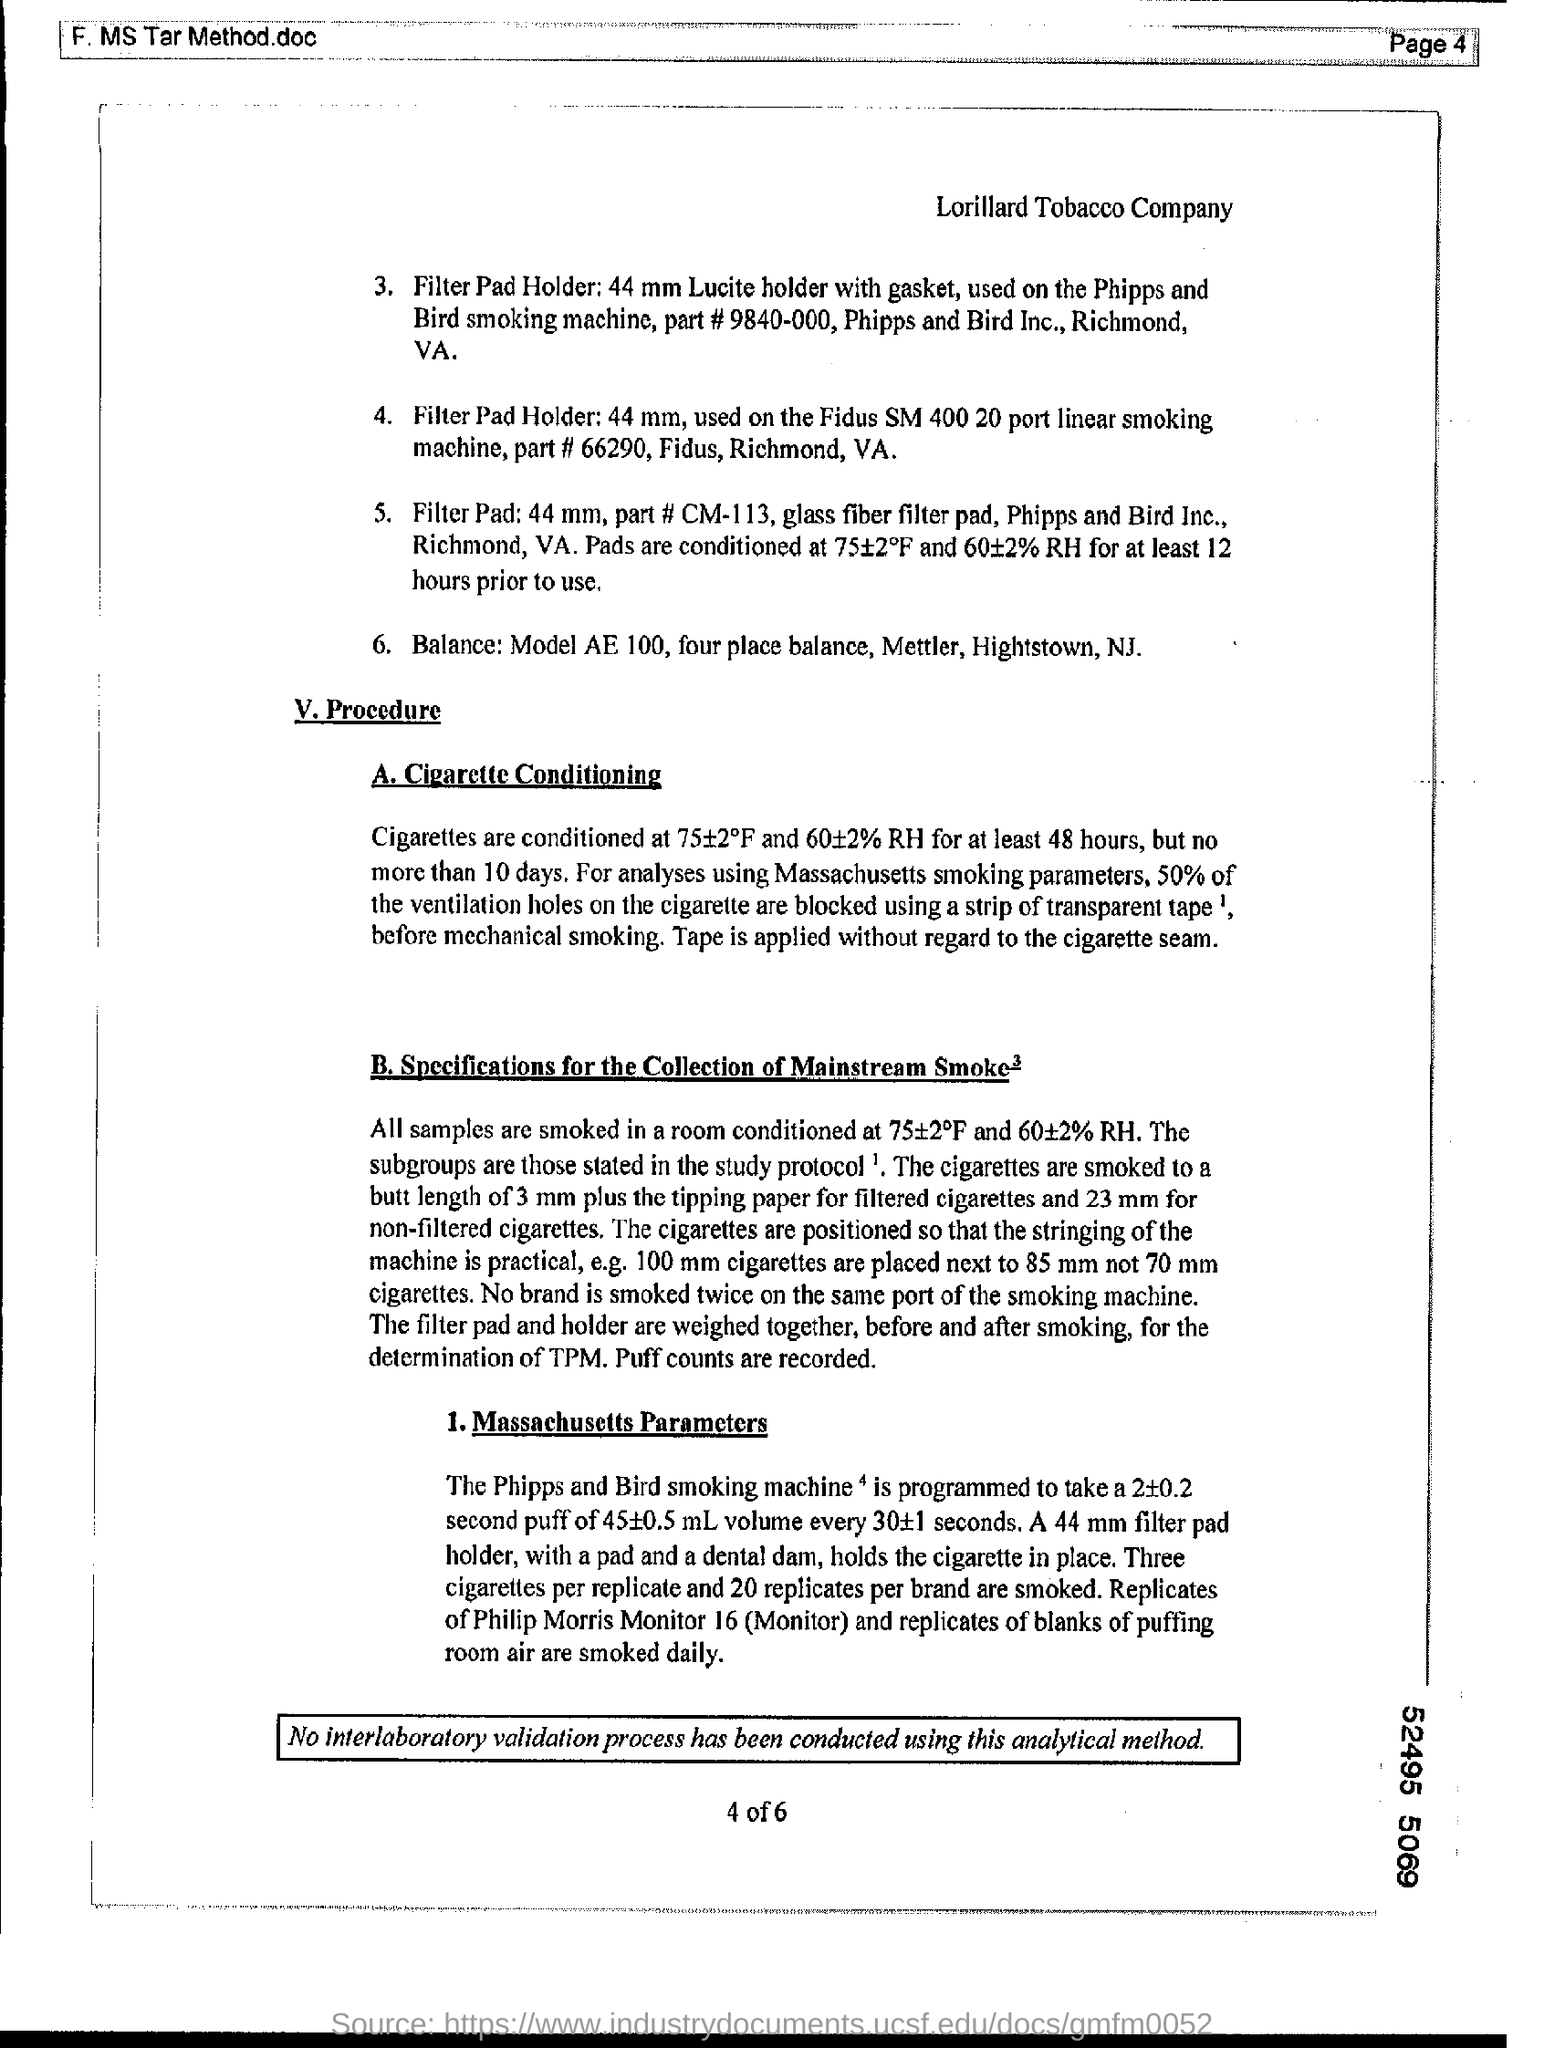Mention a couple of crucial points in this snapshot. Approximately 50% of the ventilation holes on cigarettes are blocked, which can negatively impact the smoker's health. After being conditioned, cigarettes are conditioned for a period of 48 hours. 